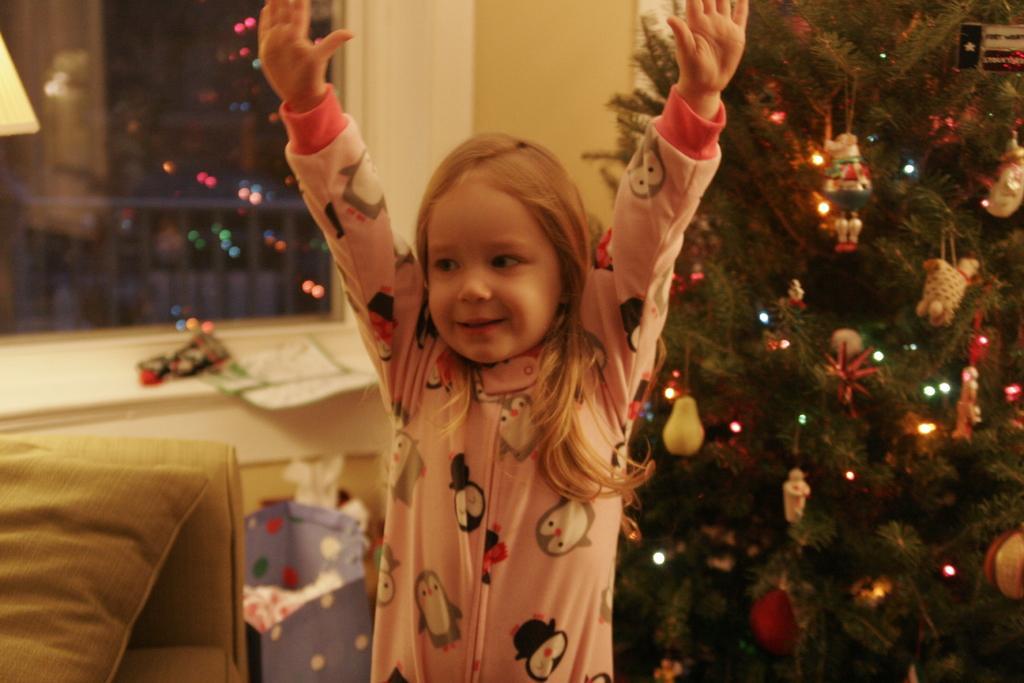How would you summarize this image in a sentence or two? In this picture there is a kid raised her hands upwards and there is a sofa and a pillow in the left corner and there is a tree decorated with few lights and some other objects in the right corner. 